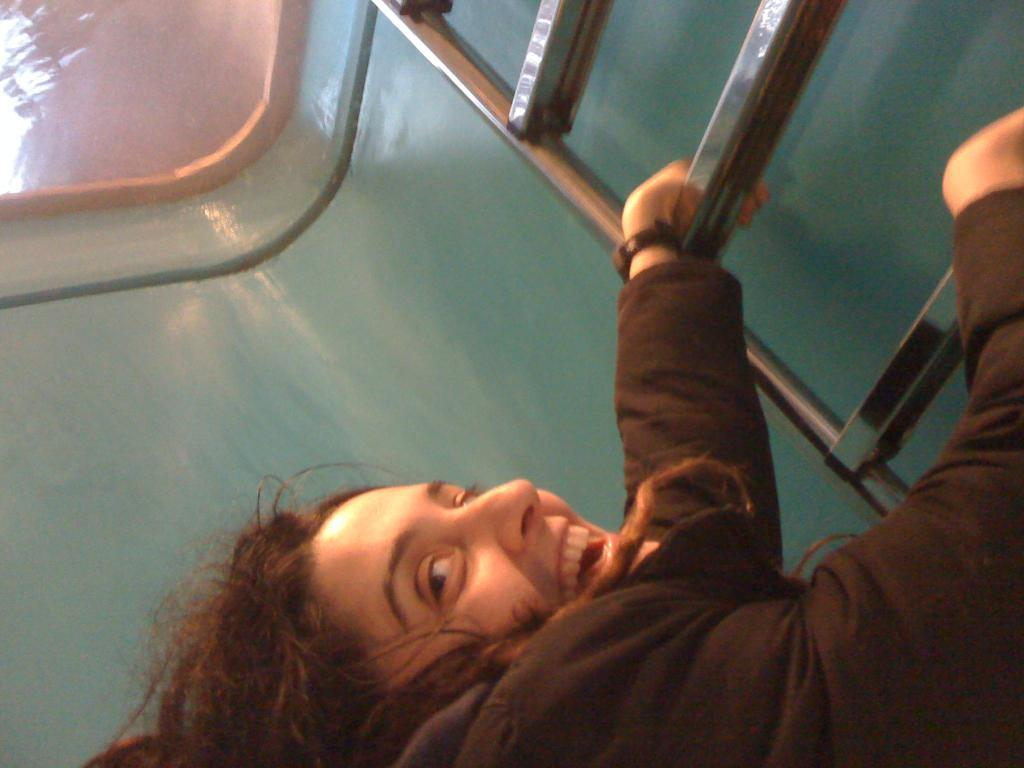Who is the main subject in the image? There is a lady in the image. What is the lady doing in the image? The lady is climbing on a ladder. What type of shoes is the farmer wearing in the image? There is no farmer or shoes mentioned in the image; it only features a lady climbing on a ladder. 